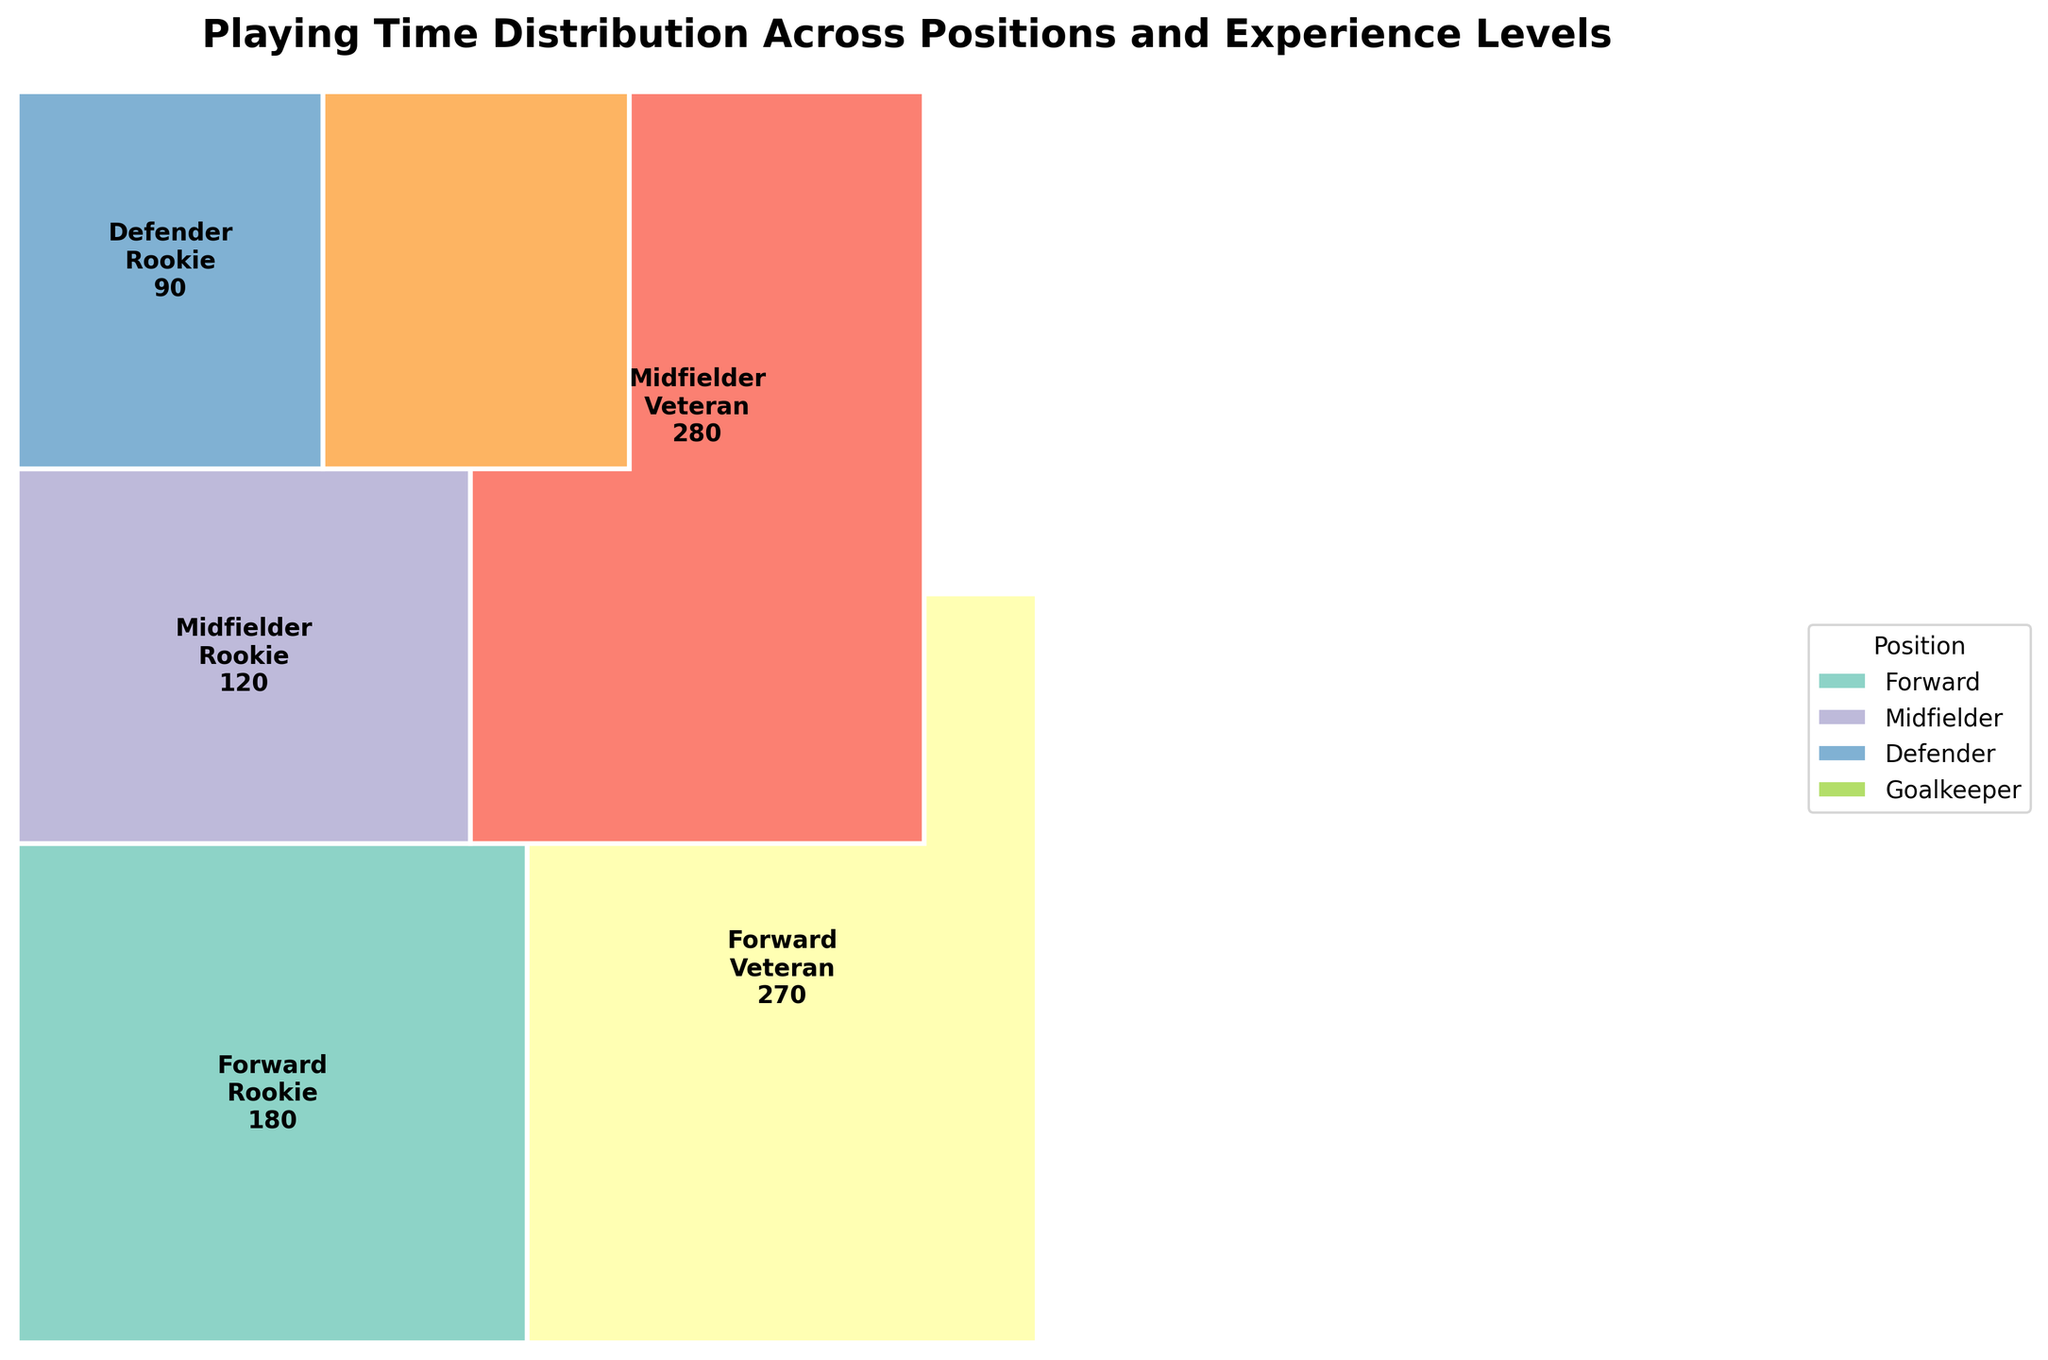What are the categories shown in the mosaic plot? The mosaic plot shows playing time distribution across team positions and player experience levels. The categories include four positions: Forward, Midfielder, Defender, and Goalkeeper, and two experience levels: Rookie and Veteran.
Answer: There are four positions and two experience levels Which position has the highest playing time for Veterans? We need to look for the largest rectangle area under the Veteran experience category. The Midfielder position has the highest playing time for Veteran players as indicated by the larger area of its section.
Answer: Midfielder What is the total playing time for Rookie players in the Forward and Goalkeeper positions? From the plot, the Forward position for Rookie players has a 120 playing time, and the Goalkeeper position for Rookie players has a 90 playing time. Adding these gives 120 + 90.
Answer: 210 How does the playing time of Veteran Defenders compare to Rookie Defenders? We compare the areas for Veteran and Rookie players in the Defender position. The Veteran Defenders have a playing time of 270, whereas Rookie Defenders have 180.
Answer: Veterans have 90 more playing time than Rookies Which position and experience level combination has the lowest playing time? Look for the smallest rectangle area in the plot. The Goalkeeper position for Rookie players has the smallest area indicating a playing time of 90.
Answer: Goalkeeper Rookies Which experience level accumulates more playing time across all positions? Summing the total playing times for Veteran and Rookie rectangles for all positions and comparing them, Veterans have generally larger areas, indicating a higher total playing time across all positions.
Answer: Veterans What percentage of the total playing time does the Midfielder Rookie category occupy? Calculate the percentage by finding the area of the Midfielder-Rookie section (150), divide it by the total playing time (1210), and multiply by 100. (150 / 1210) * 100 ≈ 12.4%
Answer: 12.4% Is the playing time distributed evenly across all positions and experience levels? Examining the areas of the rectangles for each position and experience level, we observe that the areas vary significantly, indicating that the playing time is not evenly distributed.
Answer: No Which position shows the most balanced playing time between Rookies and Veterans? Compare the balance of areas within each position. The Goalkeeper position shows a relatively balanced distribution between Rookies (90) and Veterans (180), though not perfectly equal.
Answer: Goalkeeper How does the total playing time of Forwards compare to that of Midfielders? Summing the areas for both Rookies and Veterans within each position: For Forwards: 120 (Rookies) + 280 (Veterans) = 400. For Midfielders: 150 (Rookies) + 300 (Veterans) = 450.
Answer: Midfielders have more total playing time by 50 